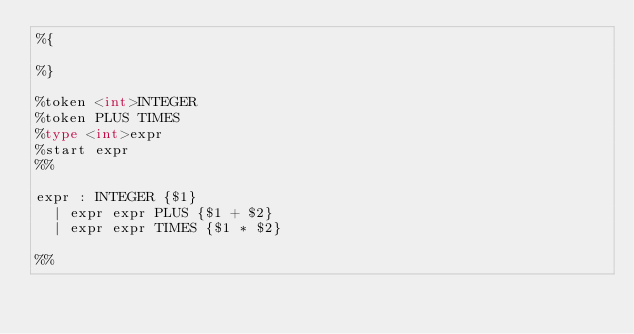Convert code to text. <code><loc_0><loc_0><loc_500><loc_500><_OCaml_>%{

%}

%token <int>INTEGER
%token PLUS TIMES
%type <int>expr
%start expr
%%

expr : INTEGER {$1}
  | expr expr PLUS {$1 + $2}
  | expr expr TIMES {$1 * $2}

%%


  



  
</code> 